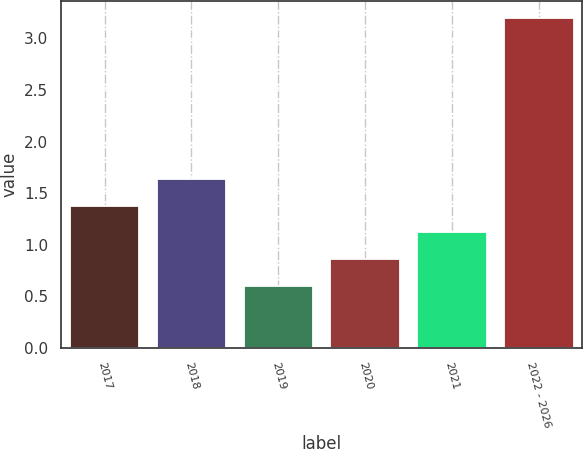<chart> <loc_0><loc_0><loc_500><loc_500><bar_chart><fcel>2017<fcel>2018<fcel>2019<fcel>2020<fcel>2021<fcel>2022 - 2026<nl><fcel>1.38<fcel>1.64<fcel>0.6<fcel>0.86<fcel>1.12<fcel>3.2<nl></chart> 